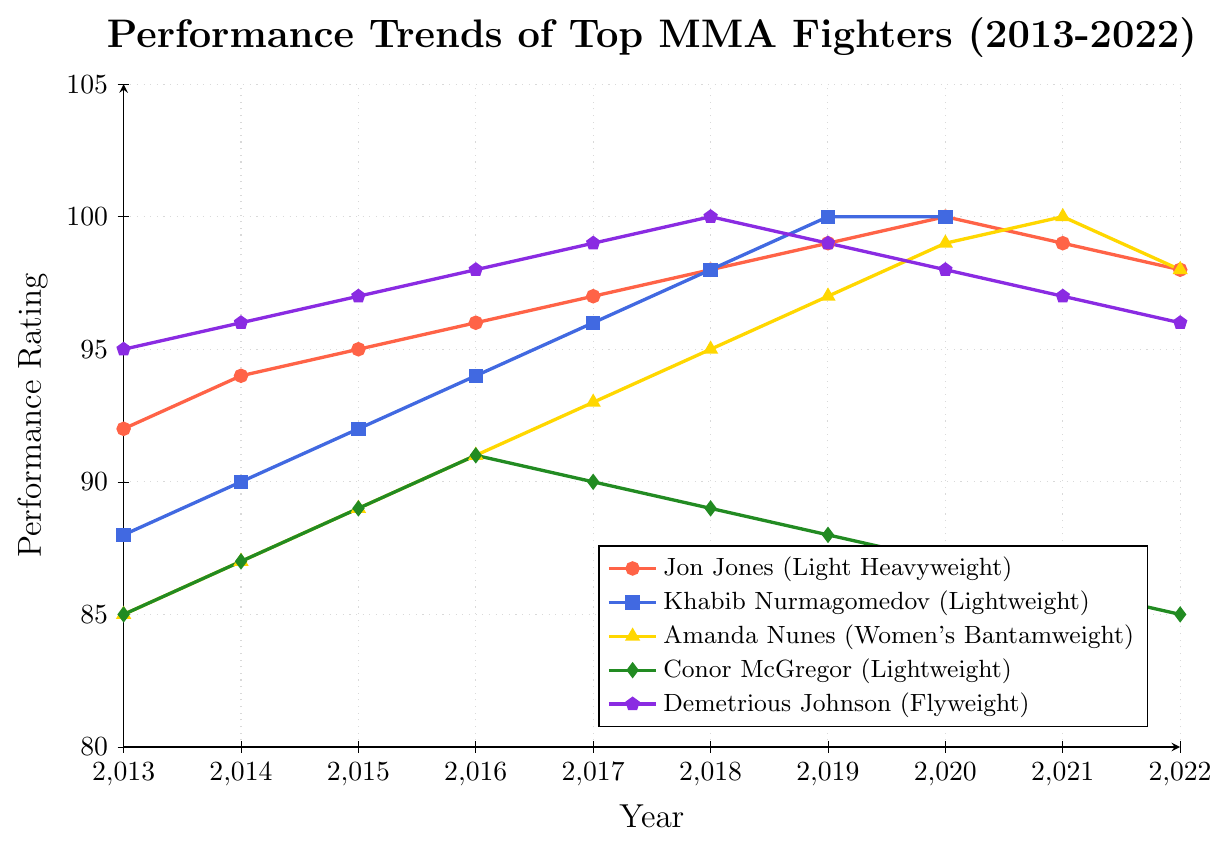Which fighter shows the most consistent improvement over the years? To answer this, we need to look at the line plots of all fighters to see who has a consistently ascending trend without significant dips. Jon Jones shows an almost linear improvement from 2013 to 2020, followed by a slight decrease afterward. Khabib Nurmagomedov also shows consistent improvement until 2019, maintaining his peak till 2020. Other fighters like Amanda Nunes and Demetrious Johnson show a slight decline after their peak.
Answer: Khabib Nurmagomedov Which fighter's performance peaked in the year 2020? By observing the peaks in 2020, Jon Jones, Khabib Nurmagomedov, Amanda Nunes, and Demetrious Johnson reached their highest ratings in this year, though Khabib and Demetrious tied their peak ratings with previous years. Jon Jones and Amanda Nunes have higher values in 2020.
Answer: Jon Jones, Amanda Nunes Compare the performance trends of Jon Jones and Conor McGregor from 2013 to 2022. Whose performance shows a greater overall improvement? Jon Jones starts at 92 in 2013 and peaks at 100 in 2020 before declining to 98 in 2022. His total improvement is 6 points. Conor McGregor starts at 85 in 2013 and peaks at 91 in 2016 then drops back to 85 in 2022. Thus, Conor shows no overall improvement. Jon Jones shows a greater improvement.
Answer: Jon Jones Who had the highest performance rating in 2018? By observing the year 2018, both Jon Jones and Demetrious Johnson had a rating of 100. Comparing all fighters for this year, these two are the highest.
Answer: Jon Jones, Demetrious Johnson Was there any fighter whose performance declined continuously after reaching their peak? If yes, who? To determine this, it's necessary to examine each fighter's trend post-peak. Amanda Nunes (peak 2021, slight drop), Jon Jones (peak 2020, slight drop), Demetrious Johnson (peak 2018, continuous decline). The most noticeable decline is Demetrious Johnson.
Answer: Demetrious Johnson Which weight class has the most prominent performance trend over the decade? By cross-referencing weight classes and performance trends, Jon Jones (Light Heavyweight), Khabib Nurmagomedov (Lightweight), Amanda Nunes (Women's Bantamweight), Conor McGregor (Lightweight), and Demetrious Johnson (Flyweight) were assessed. The Light Heavyweight class with Jon Jones shows the highest and most consistent improvement over the decade.
Answer: Light Heavyweight 